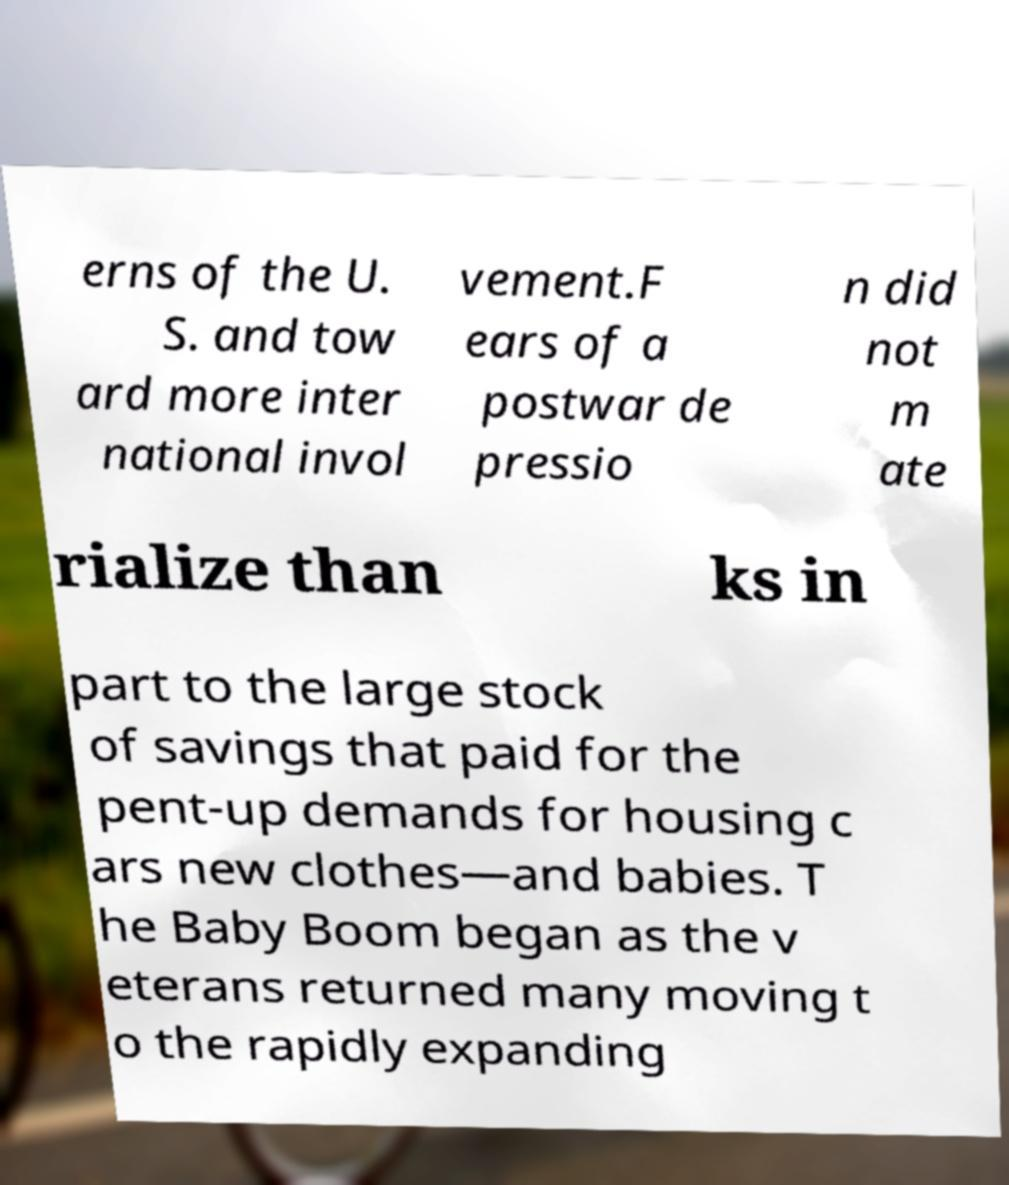Can you read and provide the text displayed in the image?This photo seems to have some interesting text. Can you extract and type it out for me? erns of the U. S. and tow ard more inter national invol vement.F ears of a postwar de pressio n did not m ate rialize than ks in part to the large stock of savings that paid for the pent-up demands for housing c ars new clothes—and babies. T he Baby Boom began as the v eterans returned many moving t o the rapidly expanding 